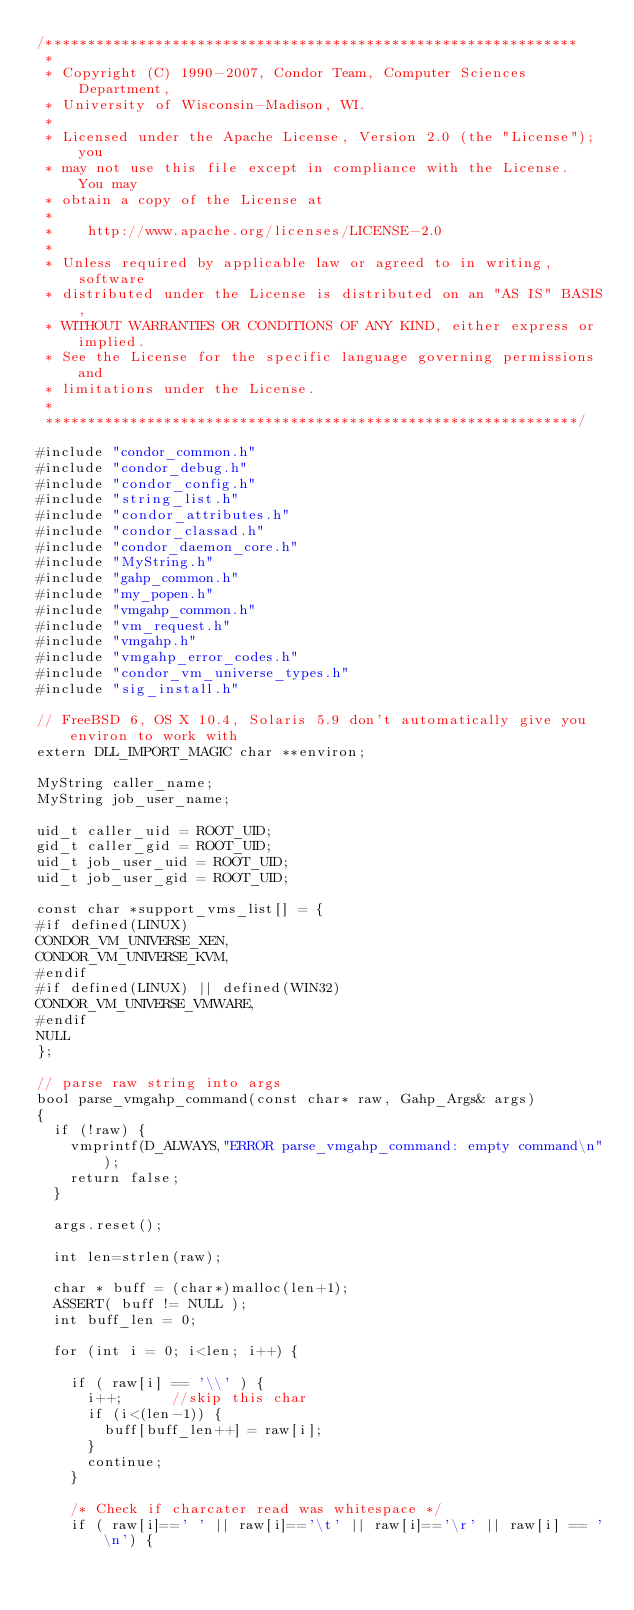<code> <loc_0><loc_0><loc_500><loc_500><_C++_>/***************************************************************
 *
 * Copyright (C) 1990-2007, Condor Team, Computer Sciences Department,
 * University of Wisconsin-Madison, WI.
 * 
 * Licensed under the Apache License, Version 2.0 (the "License"); you
 * may not use this file except in compliance with the License.  You may
 * obtain a copy of the License at
 * 
 *    http://www.apache.org/licenses/LICENSE-2.0
 * 
 * Unless required by applicable law or agreed to in writing, software
 * distributed under the License is distributed on an "AS IS" BASIS,
 * WITHOUT WARRANTIES OR CONDITIONS OF ANY KIND, either express or implied.
 * See the License for the specific language governing permissions and
 * limitations under the License.
 *
 ***************************************************************/

#include "condor_common.h"
#include "condor_debug.h"
#include "condor_config.h"
#include "string_list.h"
#include "condor_attributes.h"
#include "condor_classad.h"
#include "condor_daemon_core.h"
#include "MyString.h"
#include "gahp_common.h"
#include "my_popen.h"
#include "vmgahp_common.h"
#include "vm_request.h"
#include "vmgahp.h"
#include "vmgahp_error_codes.h"
#include "condor_vm_universe_types.h"
#include "sig_install.h"

// FreeBSD 6, OS X 10.4, Solaris 5.9 don't automatically give you environ to work with
extern DLL_IMPORT_MAGIC char **environ;

MyString caller_name;
MyString job_user_name;

uid_t caller_uid = ROOT_UID;
gid_t caller_gid = ROOT_UID;
uid_t job_user_uid = ROOT_UID;
uid_t job_user_gid = ROOT_UID;

const char *support_vms_list[] = {
#if defined(LINUX)
CONDOR_VM_UNIVERSE_XEN,
CONDOR_VM_UNIVERSE_KVM,
#endif
#if defined(LINUX) || defined(WIN32)
CONDOR_VM_UNIVERSE_VMWARE,
#endif
NULL
};

// parse raw string into args
bool parse_vmgahp_command(const char* raw, Gahp_Args& args) 
{
	if (!raw) {
		vmprintf(D_ALWAYS,"ERROR parse_vmgahp_command: empty command\n");
		return false;
	}

	args.reset();

	int len=strlen(raw);

	char * buff = (char*)malloc(len+1);
	ASSERT( buff != NULL );
	int buff_len = 0;

	for (int i = 0; i<len; i++) {

		if ( raw[i] == '\\' ) {
			i++; 			//skip this char
			if (i<(len-1)) {
				buff[buff_len++] = raw[i];
			}
			continue;
		}

		/* Check if charcater read was whitespace */
		if ( raw[i]==' ' || raw[i]=='\t' || raw[i]=='\r' || raw[i] == '\n') {
</code> 